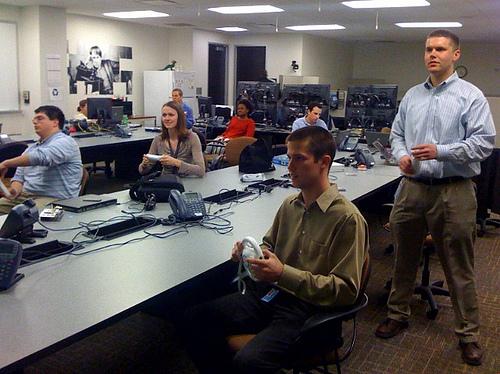How many people in this photo appear to be holding gaming controllers?
Answer briefly. 4. How many people are standing?
Give a very brief answer. 1. Is the man standing using the telephone?
Be succinct. No. 